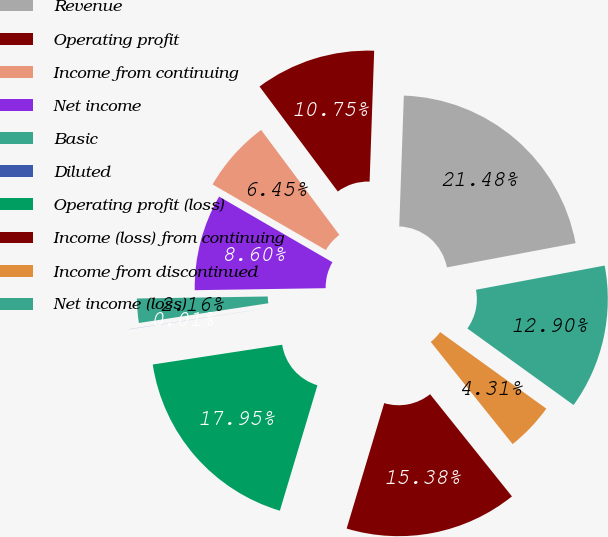Convert chart. <chart><loc_0><loc_0><loc_500><loc_500><pie_chart><fcel>Revenue<fcel>Operating profit<fcel>Income from continuing<fcel>Net income<fcel>Basic<fcel>Diluted<fcel>Operating profit (loss)<fcel>Income (loss) from continuing<fcel>Income from discontinued<fcel>Net income (loss)<nl><fcel>21.48%<fcel>10.75%<fcel>6.45%<fcel>8.6%<fcel>2.16%<fcel>0.01%<fcel>17.95%<fcel>15.38%<fcel>4.31%<fcel>12.9%<nl></chart> 